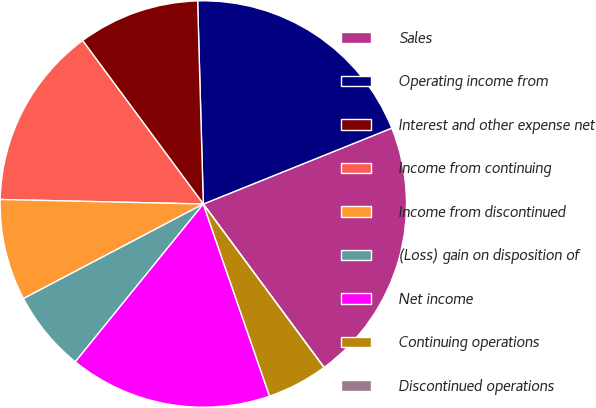Convert chart to OTSL. <chart><loc_0><loc_0><loc_500><loc_500><pie_chart><fcel>Sales<fcel>Operating income from<fcel>Interest and other expense net<fcel>Income from continuing<fcel>Income from discontinued<fcel>(Loss) gain on disposition of<fcel>Net income<fcel>Continuing operations<fcel>Discontinued operations<nl><fcel>20.97%<fcel>19.35%<fcel>9.68%<fcel>14.52%<fcel>8.06%<fcel>6.45%<fcel>16.13%<fcel>4.84%<fcel>0.0%<nl></chart> 